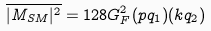Convert formula to latex. <formula><loc_0><loc_0><loc_500><loc_500>\overline { | M _ { S M } | ^ { 2 } } = 1 2 8 G _ { F } ^ { 2 } ( p q _ { 1 } ) ( k q _ { 2 } )</formula> 